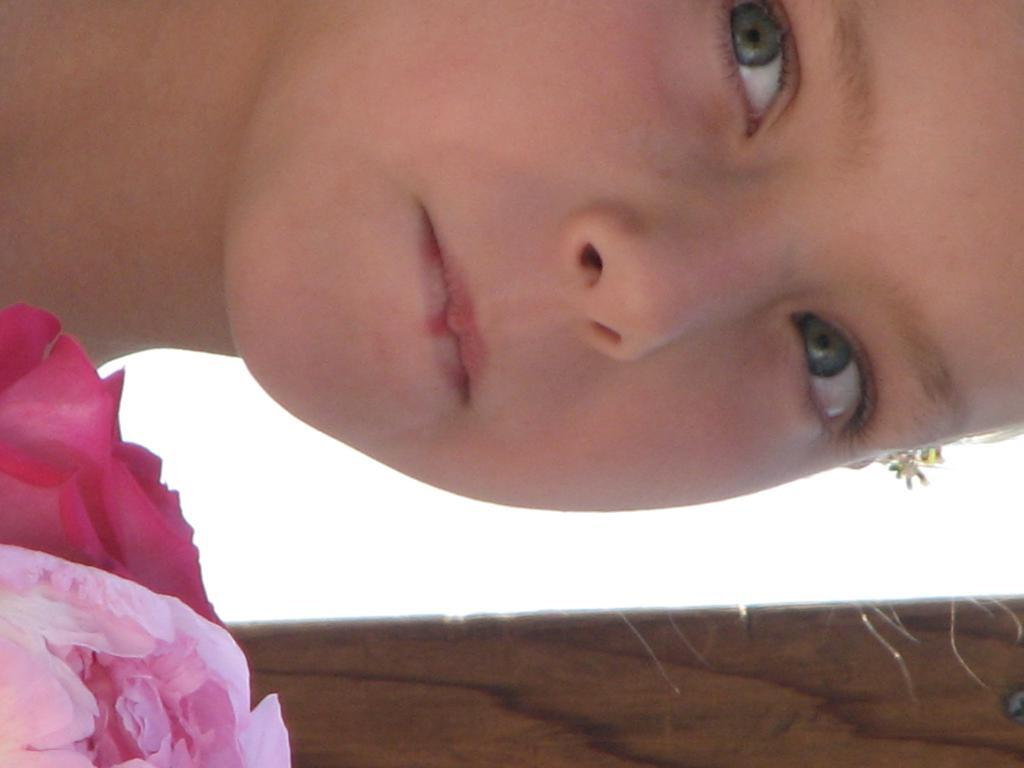What is located in the bottom left-hand side of the image? There is a cloth in the bottom left-hand side of the image. Can you describe the person at the top of the image? Unfortunately, the provided facts do not give any information about the person at the top of the image. What type of wine is being served in the image? There is no wine present in the image. How many dolls are visible in the image? There are no dolls present in the image. 